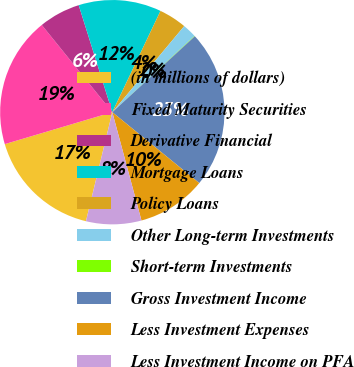Convert chart. <chart><loc_0><loc_0><loc_500><loc_500><pie_chart><fcel>(in millions of dollars)<fcel>Fixed Maturity Securities<fcel>Derivative Financial<fcel>Mortgage Loans<fcel>Policy Loans<fcel>Other Long-term Investments<fcel>Short-term Investments<fcel>Gross Investment Income<fcel>Less Investment Expenses<fcel>Less Investment Income on PFA<nl><fcel>16.63%<fcel>18.77%<fcel>5.98%<fcel>11.91%<fcel>4.01%<fcel>2.03%<fcel>0.06%<fcel>22.72%<fcel>9.93%<fcel>7.96%<nl></chart> 